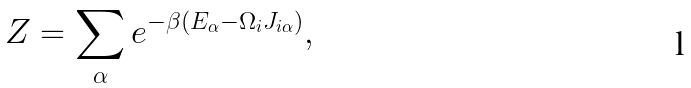Convert formula to latex. <formula><loc_0><loc_0><loc_500><loc_500>Z = \sum _ { \alpha } e ^ { - \beta ( E _ { \alpha } - \Omega _ { i } J _ { i \alpha } ) } ,</formula> 